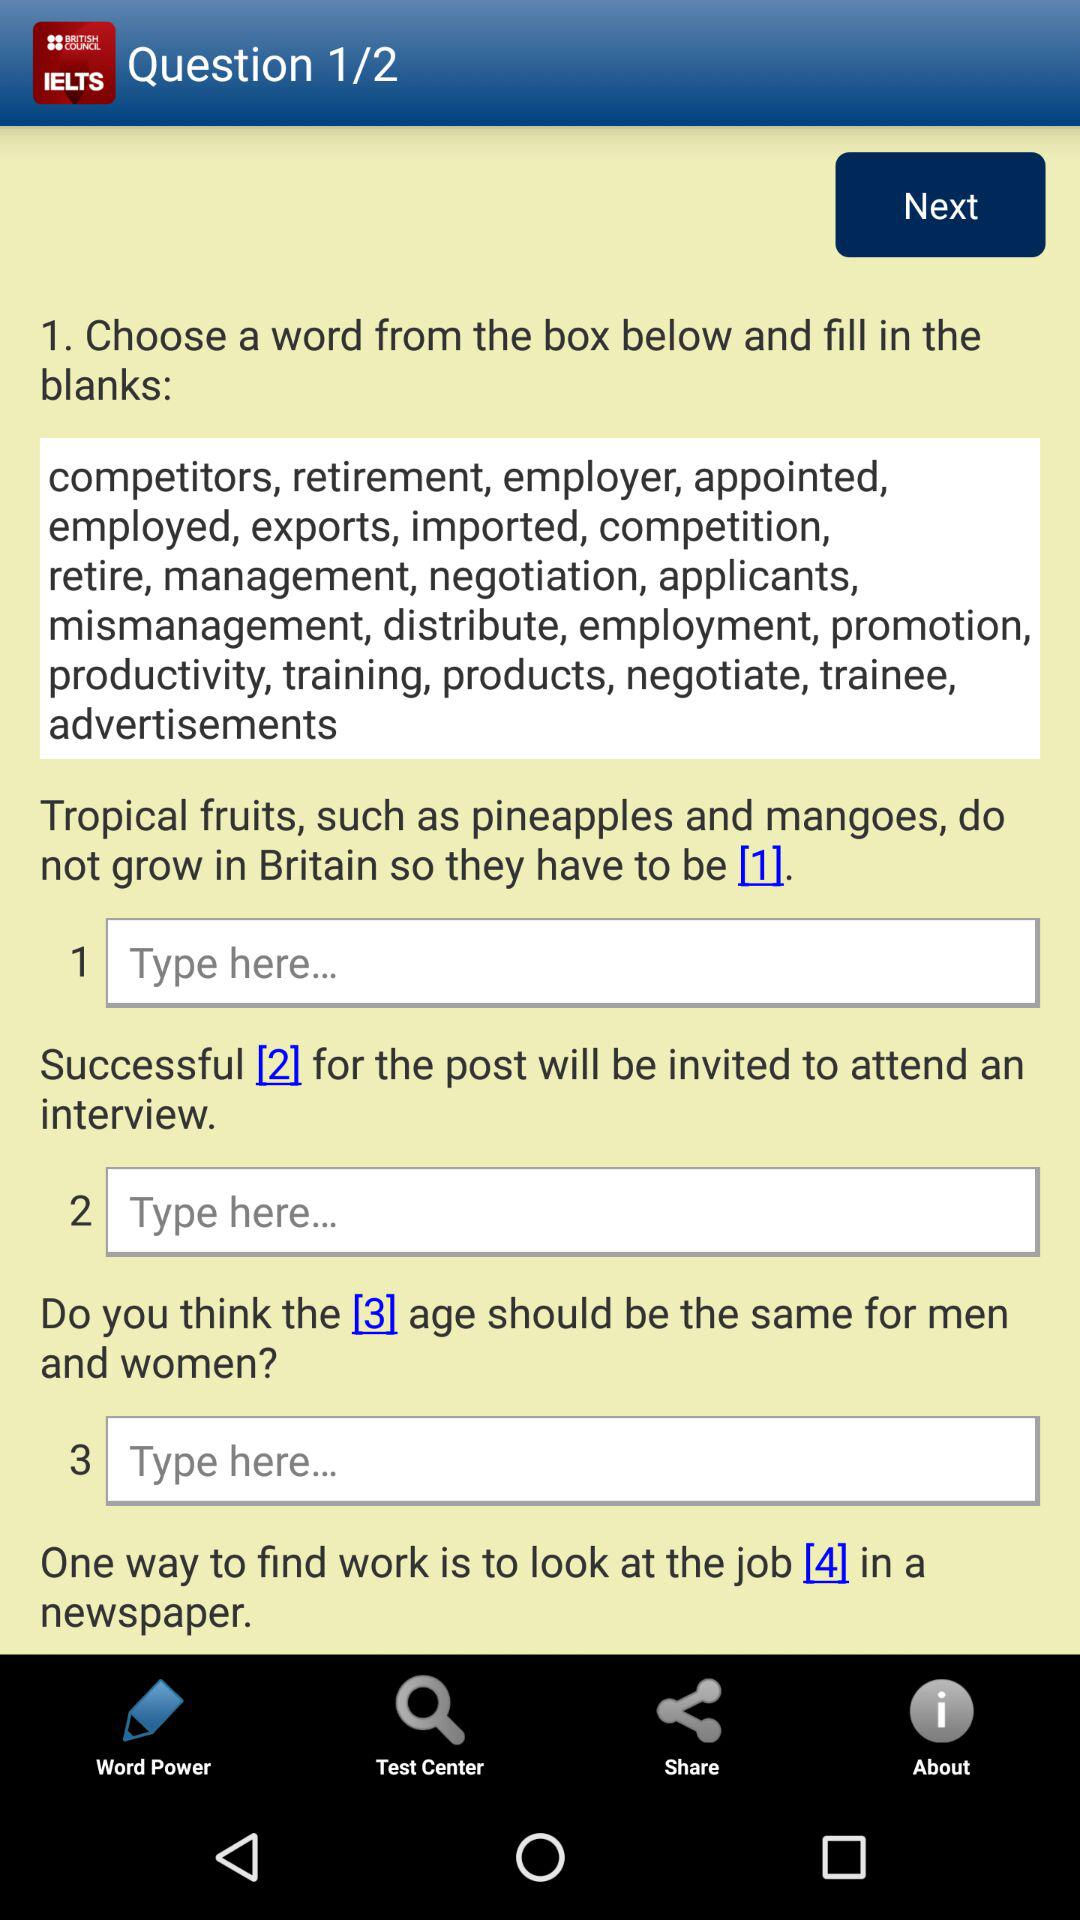Which question are we on? You are on question 1. 